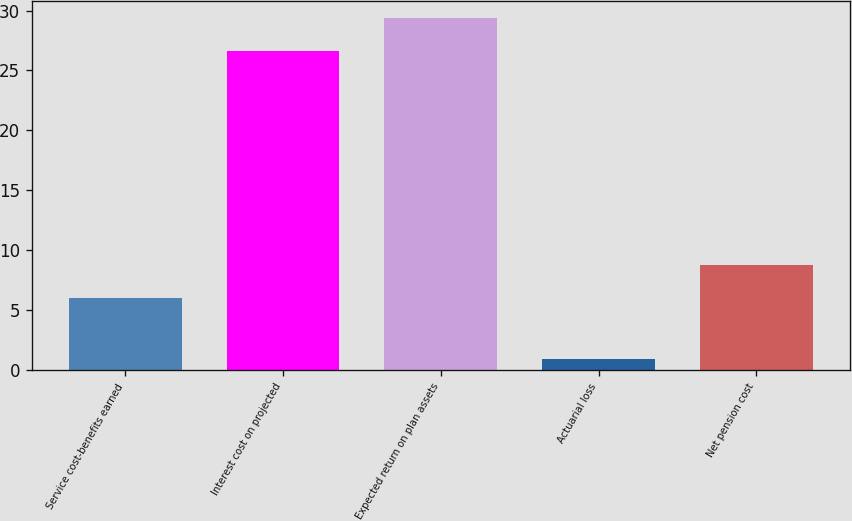Convert chart. <chart><loc_0><loc_0><loc_500><loc_500><bar_chart><fcel>Service cost-benefits earned<fcel>Interest cost on projected<fcel>Expected return on plan assets<fcel>Actuarial loss<fcel>Net pension cost<nl><fcel>6<fcel>26.6<fcel>29.34<fcel>0.9<fcel>8.74<nl></chart> 